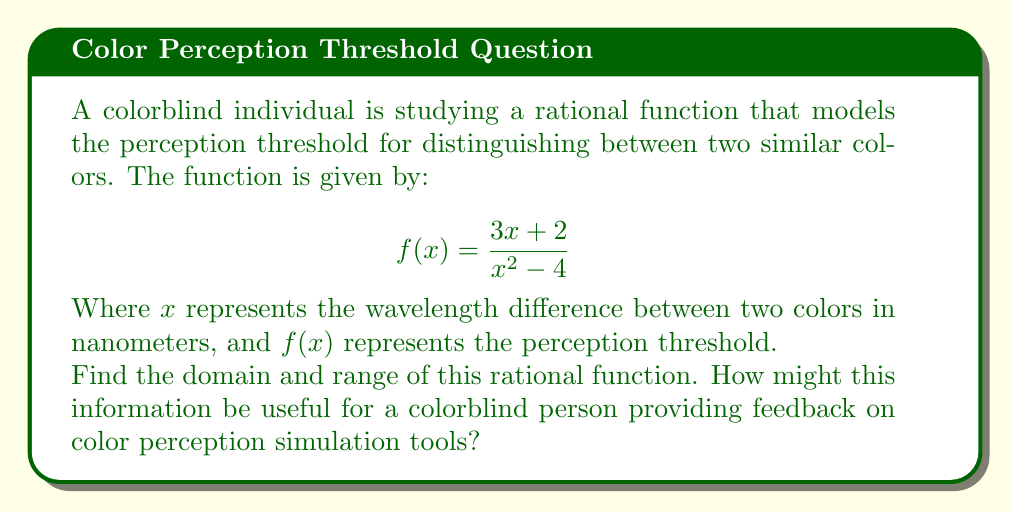Can you answer this question? Let's approach this step-by-step:

1) Domain:
   The domain of a rational function includes all real numbers except those that make the denominator zero.
   
   Set the denominator to zero and solve:
   $$x^2-4 = 0$$
   $$(x+2)(x-2) = 0$$
   $$x = -2 \text{ or } x = 2$$

   Therefore, the domain is all real numbers except -2 and 2.

2) Range:
   To find the range, let's analyze the function's behavior:

   a) As $x$ approaches infinity or negative infinity, $f(x)$ approaches 0:
      $$\lim_{x \to \pm\infty} \frac{3x+2}{x^2-4} = 0$$

   b) Near the vertical asymptotes (x = -2 and x = 2), the function approaches positive or negative infinity.

   c) To find any horizontal asymptote, we compare the degrees of the numerator and denominator:
      The numerator is of degree 1, and the denominator is of degree 2.
      This means y = 0 is a horizontal asymptote, confirming our limit calculation.

   d) To find any potential maximum or minimum, we can differentiate:
      $$f'(x) = \frac{(x^2-4)(3) - (3x+2)(2x)}{(x^2-4)^2} = \frac{-3x^2-12x+12}{(x^2-4)^2}$$
      
      Setting this to zero and solving is complex, but we can observe that the function will have a local maximum between -2 and 2, and a local minimum to the left of -2 and to the right of 2.

Therefore, the range is all real numbers.

For a colorblind individual, this information could be crucial in providing feedback on color perception simulation tools:

1) The domain (-∞, -2) ∪ (-2, 2) ∪ (2, ∞) indicates the range of wavelength differences where the model is valid.
2) The asymptotes at x = -2 and x = 2 might represent critical points where color distinction becomes extremely difficult or impossible.
3) The fact that the range includes all real numbers suggests that for any given perception threshold, there's always a corresponding wavelength difference, which could help in calibrating the simulation tools.
Answer: Domain: $x \in (-\infty, -2) \cup (-2, 2) \cup (2, \infty)$
Range: $y \in \mathbb{R}$ 